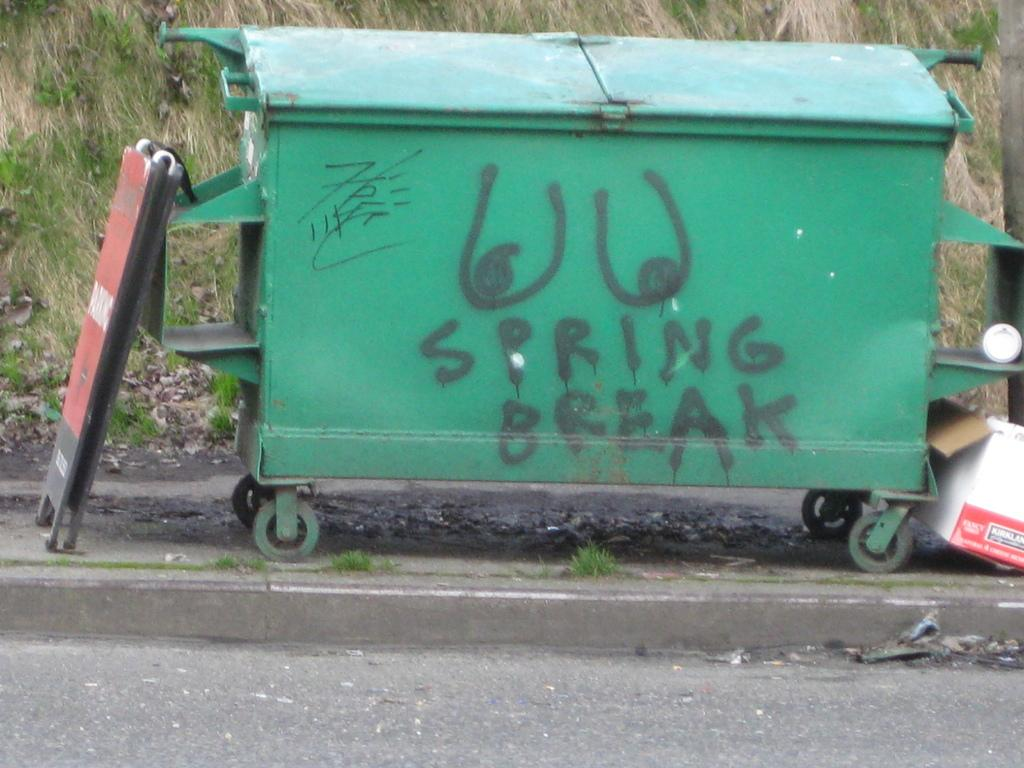<image>
Describe the image concisely. A green dumpster with graffiti on it and spray painted words "spring break" 